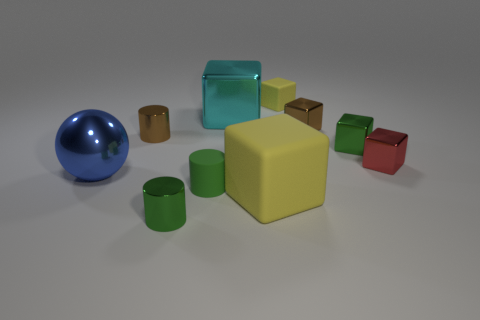Is there a big cyan object that has the same material as the big cyan block?
Offer a very short reply. No. What number of gray objects are large metallic things or metal things?
Offer a terse response. 0. There is a matte object that is on the right side of the big cyan metallic object and in front of the tiny yellow matte cube; what size is it?
Provide a short and direct response. Large. Are there more metallic spheres that are right of the cyan thing than big purple blocks?
Your response must be concise. No. What number of spheres are large blue things or big metallic objects?
Ensure brevity in your answer.  1. What is the shape of the big object that is in front of the tiny green cube and right of the blue thing?
Provide a short and direct response. Cube. Is the number of tiny things that are on the right side of the cyan object the same as the number of big blue objects behind the small yellow matte block?
Your answer should be very brief. No. What number of things are large cyan rubber cubes or small green rubber objects?
Your answer should be very brief. 1. There is a rubber block that is the same size as the rubber cylinder; what is its color?
Give a very brief answer. Yellow. What number of objects are tiny cylinders on the right side of the small brown metallic cylinder or rubber objects behind the brown shiny cube?
Provide a succinct answer. 3. 